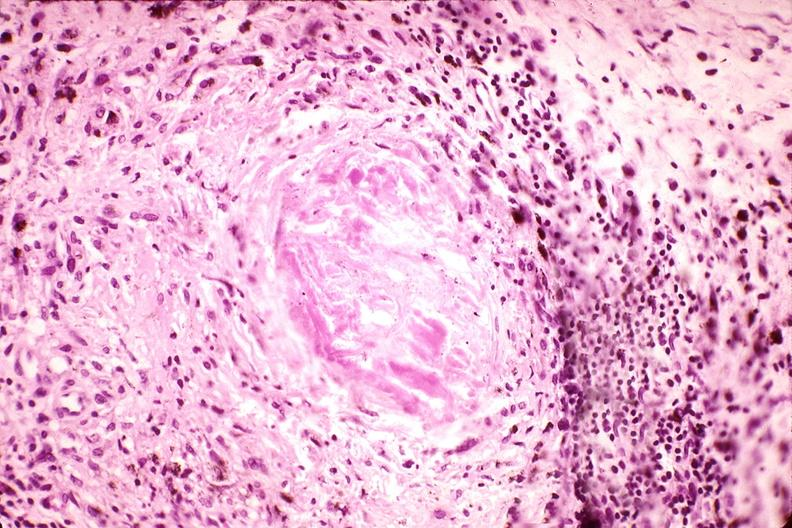does opened muscle show synovium, pannus and fibrinoid necrosis, rheumatoid arthritis?
Answer the question using a single word or phrase. No 